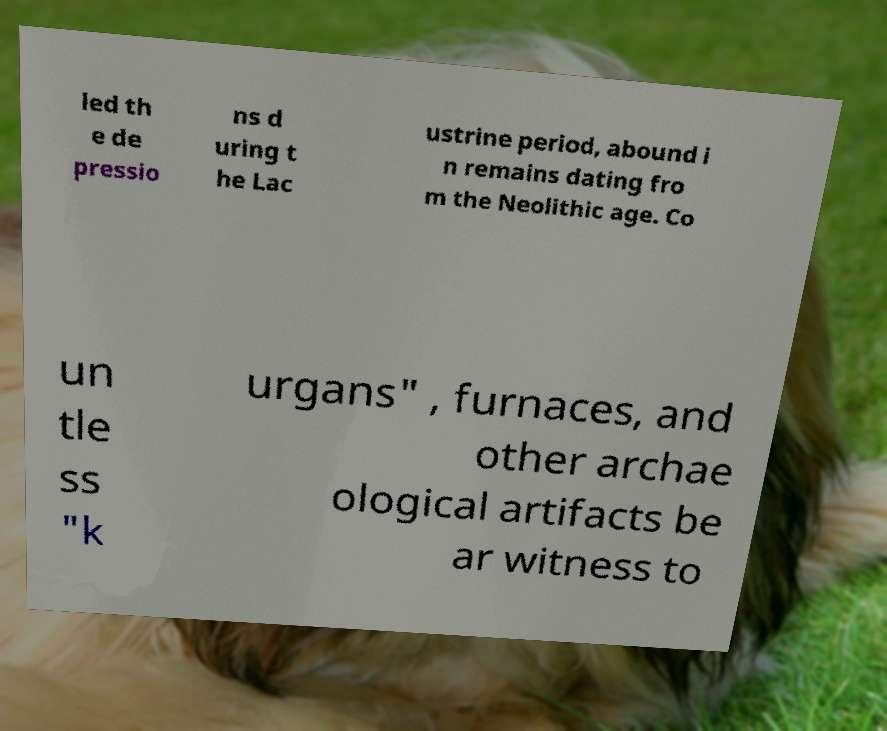Please identify and transcribe the text found in this image. led th e de pressio ns d uring t he Lac ustrine period, abound i n remains dating fro m the Neolithic age. Co un tle ss "k urgans" , furnaces, and other archae ological artifacts be ar witness to 